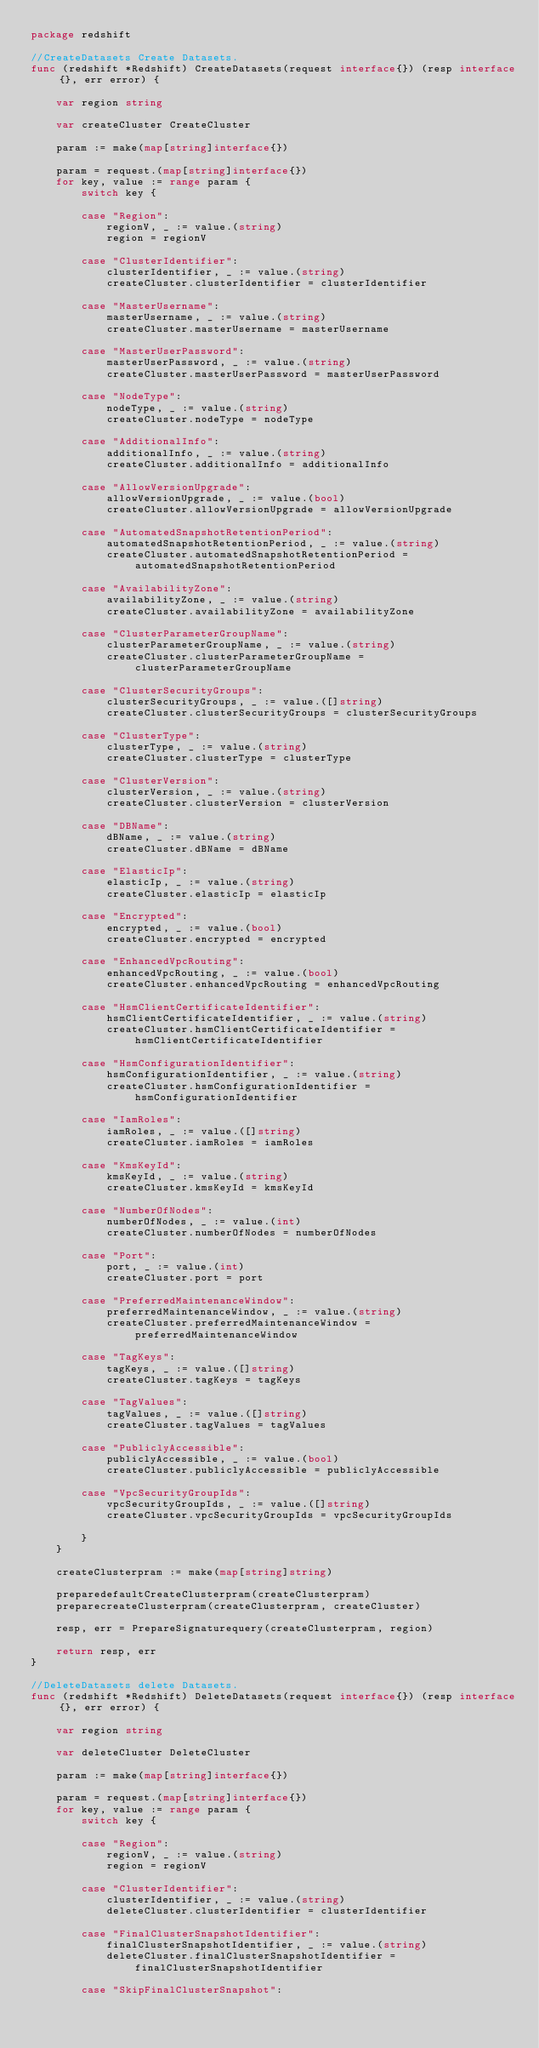Convert code to text. <code><loc_0><loc_0><loc_500><loc_500><_Go_>package redshift

//CreateDatasets Create Datasets.
func (redshift *Redshift) CreateDatasets(request interface{}) (resp interface{}, err error) {

	var region string

	var createCluster CreateCluster

	param := make(map[string]interface{})

	param = request.(map[string]interface{})
	for key, value := range param {
		switch key {

		case "Region":
			regionV, _ := value.(string)
			region = regionV

		case "ClusterIdentifier":
			clusterIdentifier, _ := value.(string)
			createCluster.clusterIdentifier = clusterIdentifier

		case "MasterUsername":
			masterUsername, _ := value.(string)
			createCluster.masterUsername = masterUsername

		case "MasterUserPassword":
			masterUserPassword, _ := value.(string)
			createCluster.masterUserPassword = masterUserPassword

		case "NodeType":
			nodeType, _ := value.(string)
			createCluster.nodeType = nodeType

		case "AdditionalInfo":
			additionalInfo, _ := value.(string)
			createCluster.additionalInfo = additionalInfo

		case "AllowVersionUpgrade":
			allowVersionUpgrade, _ := value.(bool)
			createCluster.allowVersionUpgrade = allowVersionUpgrade

		case "AutomatedSnapshotRetentionPeriod":
			automatedSnapshotRetentionPeriod, _ := value.(string)
			createCluster.automatedSnapshotRetentionPeriod = automatedSnapshotRetentionPeriod

		case "AvailabilityZone":
			availabilityZone, _ := value.(string)
			createCluster.availabilityZone = availabilityZone

		case "ClusterParameterGroupName":
			clusterParameterGroupName, _ := value.(string)
			createCluster.clusterParameterGroupName = clusterParameterGroupName

		case "ClusterSecurityGroups":
			clusterSecurityGroups, _ := value.([]string)
			createCluster.clusterSecurityGroups = clusterSecurityGroups

		case "ClusterType":
			clusterType, _ := value.(string)
			createCluster.clusterType = clusterType

		case "ClusterVersion":
			clusterVersion, _ := value.(string)
			createCluster.clusterVersion = clusterVersion

		case "DBName":
			dBName, _ := value.(string)
			createCluster.dBName = dBName

		case "ElasticIp":
			elasticIp, _ := value.(string)
			createCluster.elasticIp = elasticIp

		case "Encrypted":
			encrypted, _ := value.(bool)
			createCluster.encrypted = encrypted

		case "EnhancedVpcRouting":
			enhancedVpcRouting, _ := value.(bool)
			createCluster.enhancedVpcRouting = enhancedVpcRouting

		case "HsmClientCertificateIdentifier":
			hsmClientCertificateIdentifier, _ := value.(string)
			createCluster.hsmClientCertificateIdentifier = hsmClientCertificateIdentifier

		case "HsmConfigurationIdentifier":
			hsmConfigurationIdentifier, _ := value.(string)
			createCluster.hsmConfigurationIdentifier = hsmConfigurationIdentifier

		case "IamRoles":
			iamRoles, _ := value.([]string)
			createCluster.iamRoles = iamRoles

		case "KmsKeyId":
			kmsKeyId, _ := value.(string)
			createCluster.kmsKeyId = kmsKeyId

		case "NumberOfNodes":
			numberOfNodes, _ := value.(int)
			createCluster.numberOfNodes = numberOfNodes

		case "Port":
			port, _ := value.(int)
			createCluster.port = port

		case "PreferredMaintenanceWindow":
			preferredMaintenanceWindow, _ := value.(string)
			createCluster.preferredMaintenanceWindow = preferredMaintenanceWindow

		case "TagKeys":
			tagKeys, _ := value.([]string)
			createCluster.tagKeys = tagKeys

		case "TagValues":
			tagValues, _ := value.([]string)
			createCluster.tagValues = tagValues

		case "PubliclyAccessible":
			publiclyAccessible, _ := value.(bool)
			createCluster.publiclyAccessible = publiclyAccessible

		case "VpcSecurityGroupIds":
			vpcSecurityGroupIds, _ := value.([]string)
			createCluster.vpcSecurityGroupIds = vpcSecurityGroupIds

		}
	}

	createClusterpram := make(map[string]string)

	preparedefaultCreateClusterpram(createClusterpram)
	preparecreateClusterpram(createClusterpram, createCluster)

	resp, err = PrepareSignaturequery(createClusterpram, region)

	return resp, err
}

//DeleteDatasets delete Datasets.
func (redshift *Redshift) DeleteDatasets(request interface{}) (resp interface{}, err error) {

	var region string

	var deleteCluster DeleteCluster

	param := make(map[string]interface{})

	param = request.(map[string]interface{})
	for key, value := range param {
		switch key {

		case "Region":
			regionV, _ := value.(string)
			region = regionV

		case "ClusterIdentifier":
			clusterIdentifier, _ := value.(string)
			deleteCluster.clusterIdentifier = clusterIdentifier

		case "FinalClusterSnapshotIdentifier":
			finalClusterSnapshotIdentifier, _ := value.(string)
			deleteCluster.finalClusterSnapshotIdentifier = finalClusterSnapshotIdentifier

		case "SkipFinalClusterSnapshot":</code> 